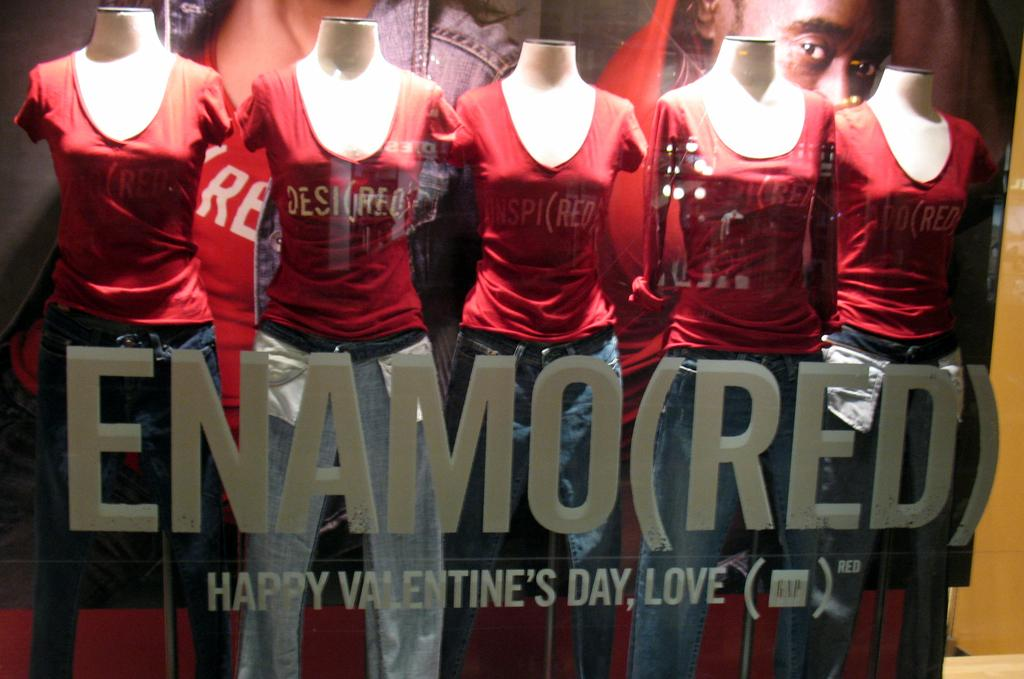<image>
Summarize the visual content of the image. The Gap is displaying a Happy Valentine's Day, Love t-shirt line. 